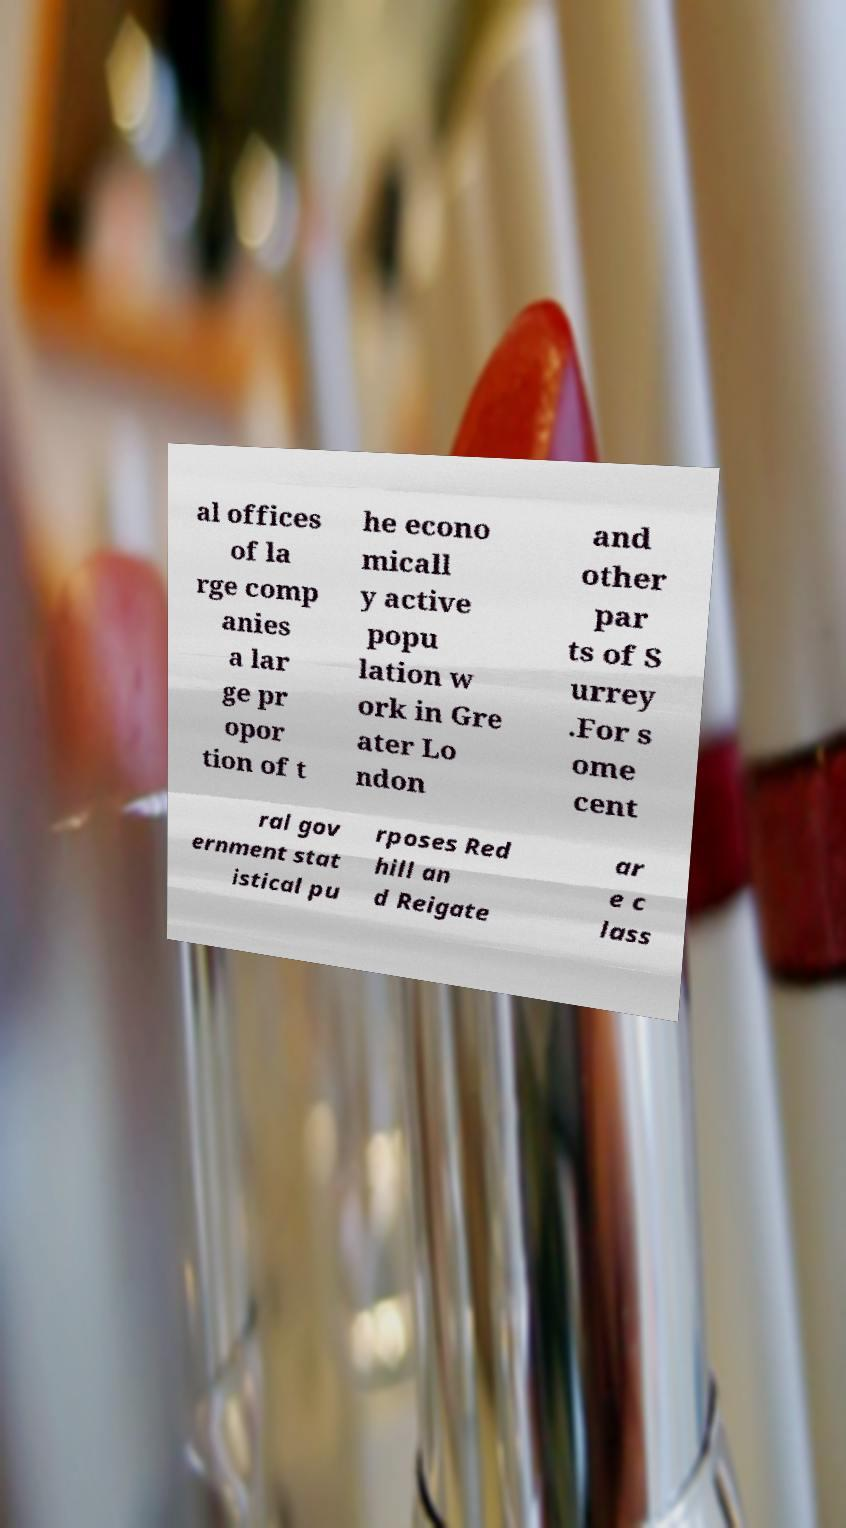Could you extract and type out the text from this image? al offices of la rge comp anies a lar ge pr opor tion of t he econo micall y active popu lation w ork in Gre ater Lo ndon and other par ts of S urrey .For s ome cent ral gov ernment stat istical pu rposes Red hill an d Reigate ar e c lass 